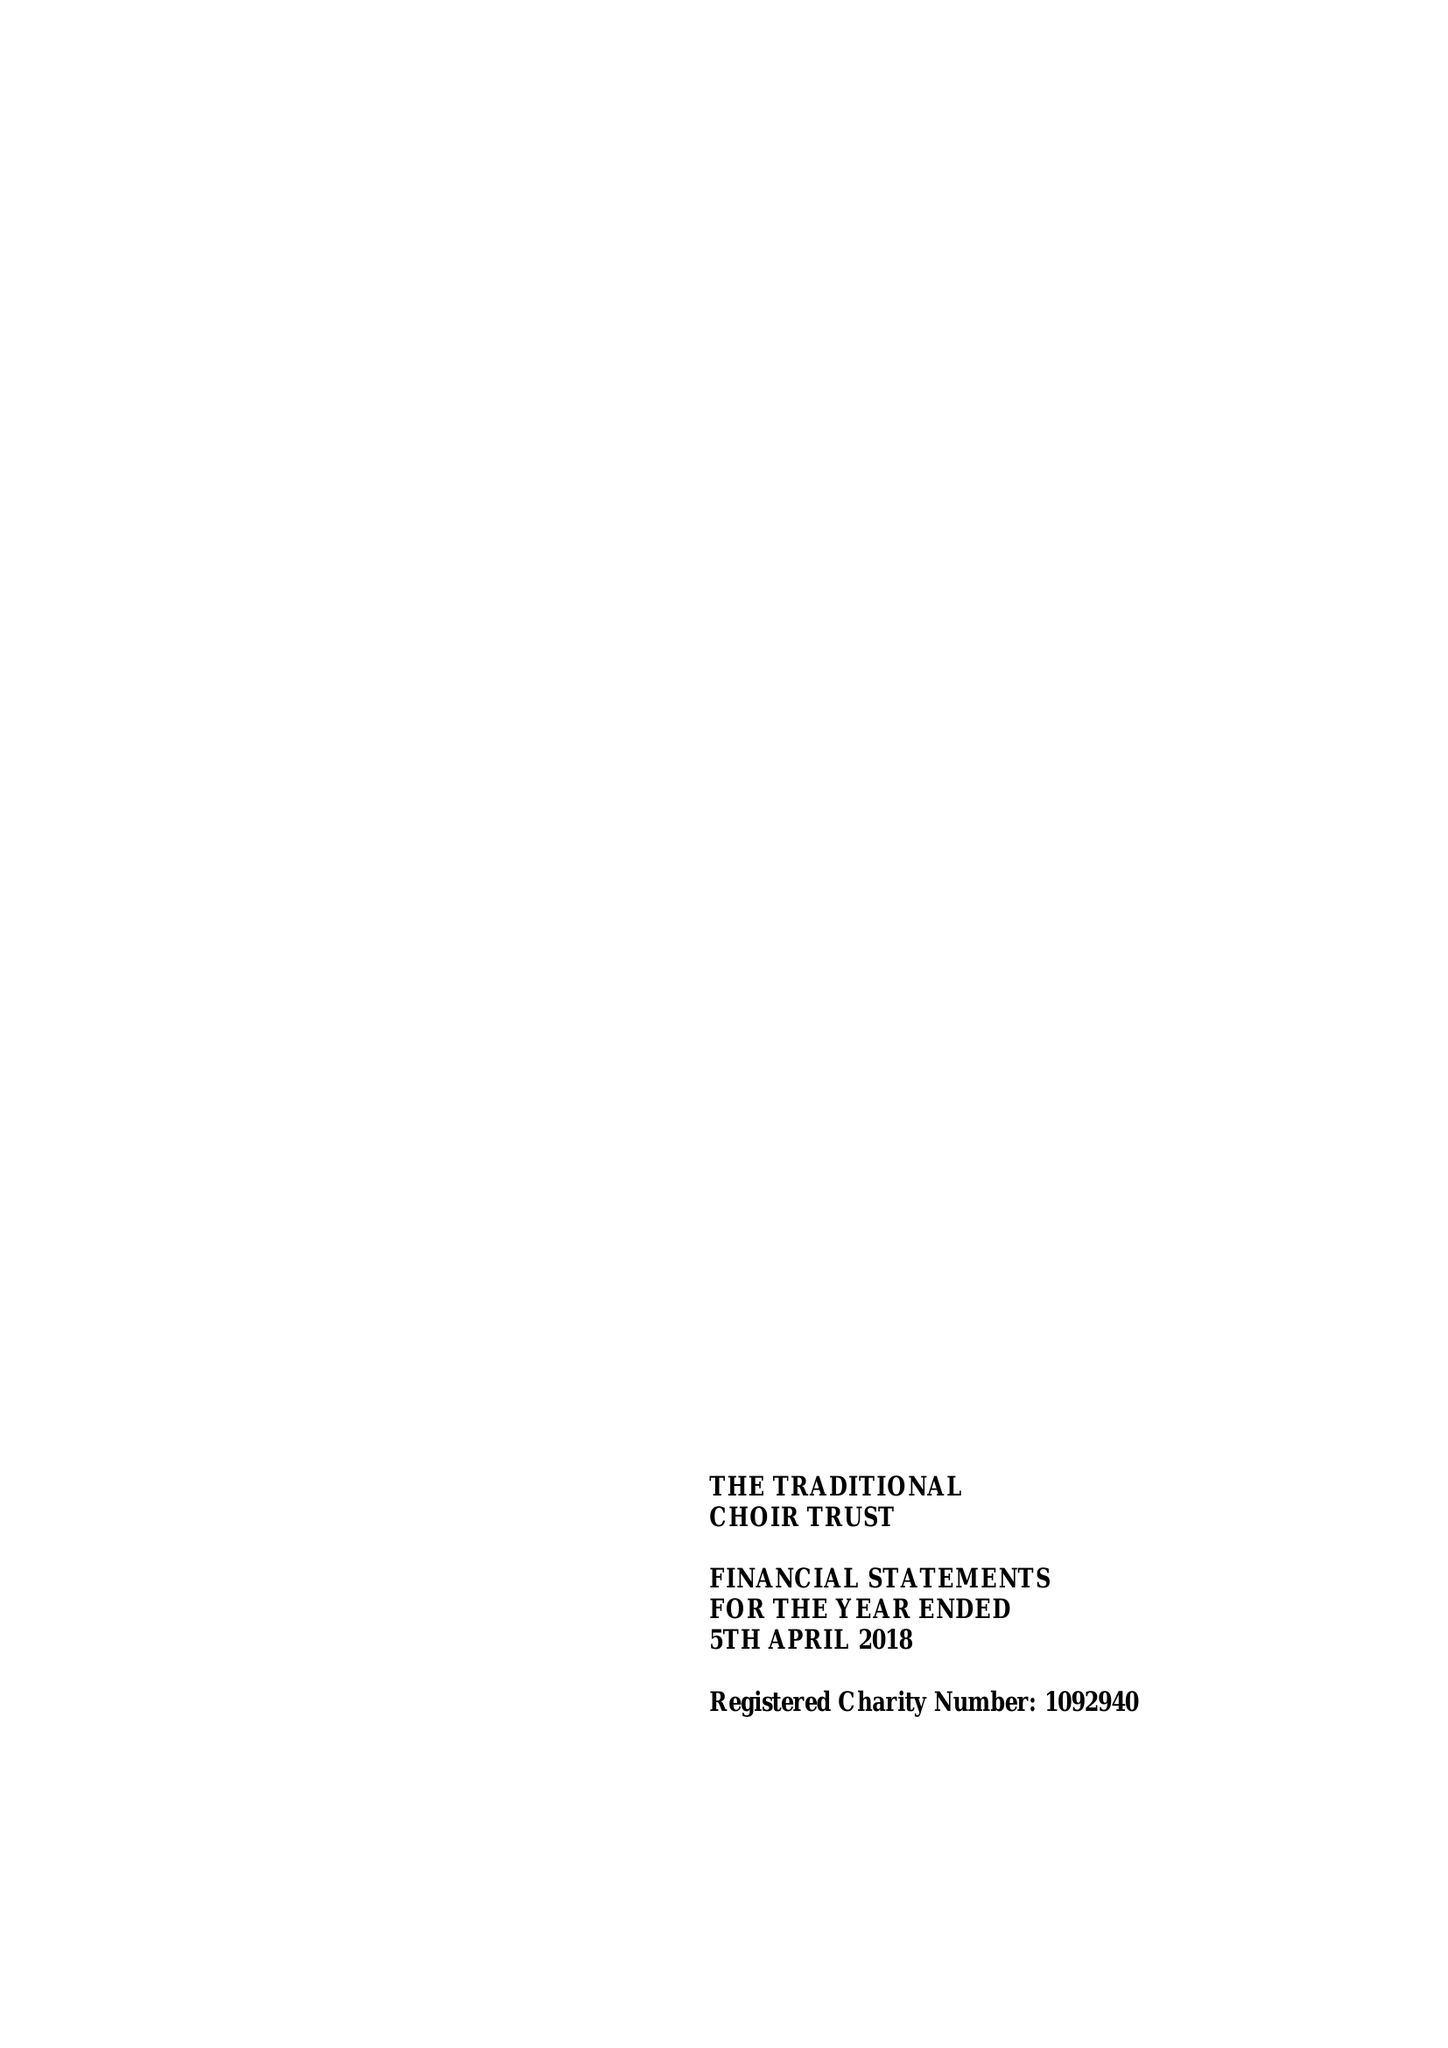What is the value for the report_date?
Answer the question using a single word or phrase. 2018-04-05 